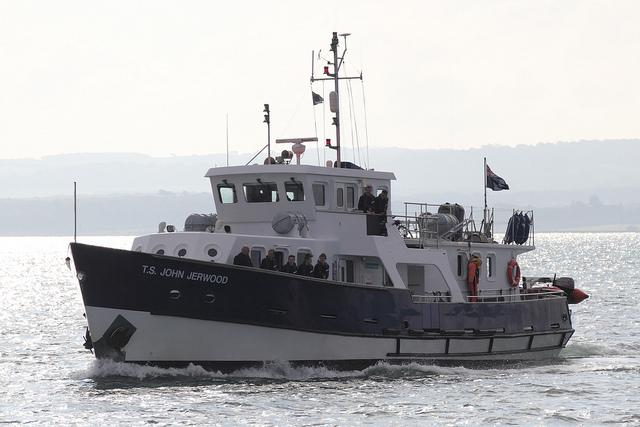Why is there writing on the boat?

Choices:
A) fleet number
B) sales ad
C) graffiti
D) boat name boat name 